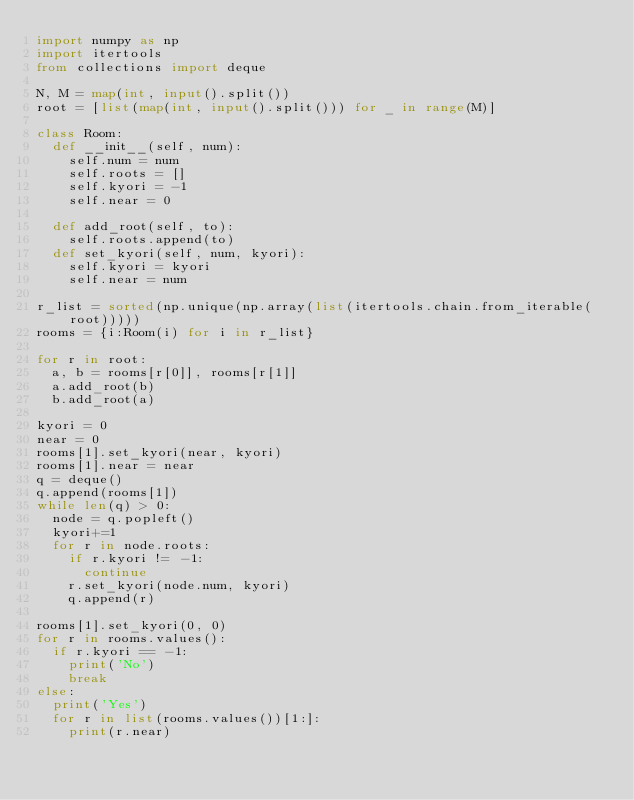<code> <loc_0><loc_0><loc_500><loc_500><_Python_>import numpy as np
import itertools
from collections import deque

N, M = map(int, input().split())
root = [list(map(int, input().split())) for _ in range(M)]

class Room:
  def __init__(self, num):
    self.num = num
    self.roots = []
    self.kyori = -1
    self.near = 0
    
  def add_root(self, to):
    self.roots.append(to)
  def set_kyori(self, num, kyori):
    self.kyori = kyori
    self.near = num

r_list = sorted(np.unique(np.array(list(itertools.chain.from_iterable(root)))))
rooms = {i:Room(i) for i in r_list}

for r in root:
  a, b = rooms[r[0]], rooms[r[1]]
  a.add_root(b)
  b.add_root(a)

kyori = 0
near = 0
rooms[1].set_kyori(near, kyori)
rooms[1].near = near
q = deque()
q.append(rooms[1])
while len(q) > 0:
  node = q.popleft()
  kyori+=1
  for r in node.roots:
    if r.kyori != -1:
      continue
    r.set_kyori(node.num, kyori)
    q.append(r)
  
rooms[1].set_kyori(0, 0)
for r in rooms.values():
  if r.kyori == -1:
    print('No')
    break
else:
  print('Yes')
  for r in list(rooms.values())[1:]:
    print(r.near) 
  
  </code> 